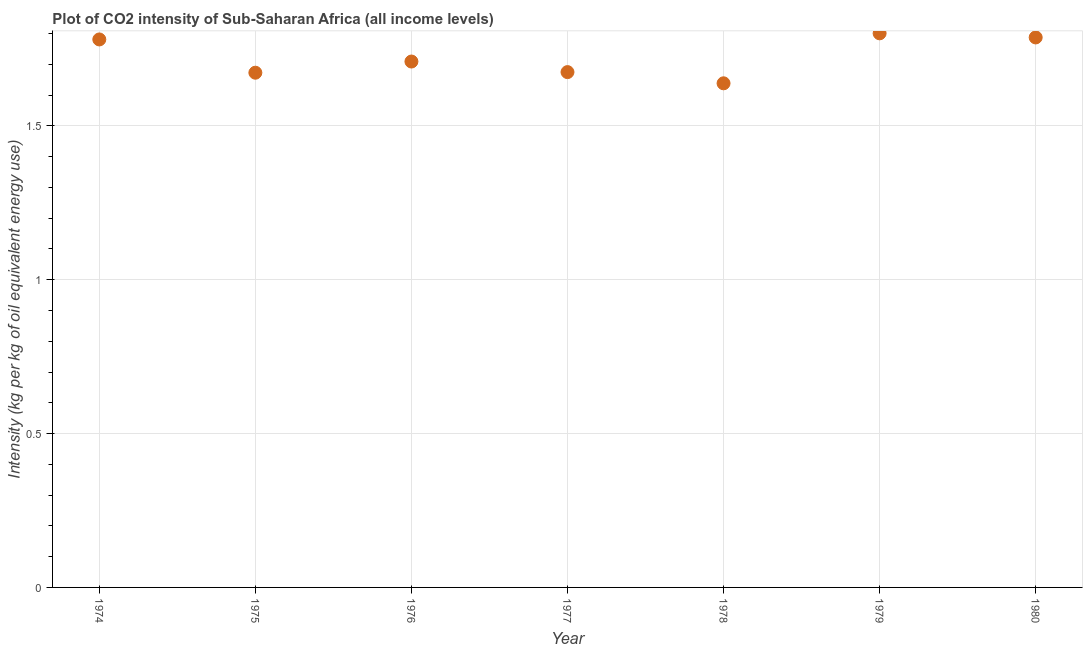What is the co2 intensity in 1980?
Your response must be concise. 1.79. Across all years, what is the maximum co2 intensity?
Your answer should be very brief. 1.8. Across all years, what is the minimum co2 intensity?
Keep it short and to the point. 1.64. In which year was the co2 intensity maximum?
Provide a short and direct response. 1979. In which year was the co2 intensity minimum?
Your answer should be very brief. 1978. What is the sum of the co2 intensity?
Make the answer very short. 12.06. What is the difference between the co2 intensity in 1974 and 1976?
Your answer should be compact. 0.07. What is the average co2 intensity per year?
Make the answer very short. 1.72. What is the median co2 intensity?
Your answer should be very brief. 1.71. In how many years, is the co2 intensity greater than 0.5 kg?
Provide a short and direct response. 7. What is the ratio of the co2 intensity in 1974 to that in 1978?
Your answer should be very brief. 1.09. Is the difference between the co2 intensity in 1974 and 1979 greater than the difference between any two years?
Your response must be concise. No. What is the difference between the highest and the second highest co2 intensity?
Offer a very short reply. 0.01. What is the difference between the highest and the lowest co2 intensity?
Give a very brief answer. 0.16. In how many years, is the co2 intensity greater than the average co2 intensity taken over all years?
Offer a very short reply. 3. How many years are there in the graph?
Provide a short and direct response. 7. Does the graph contain any zero values?
Your response must be concise. No. Does the graph contain grids?
Give a very brief answer. Yes. What is the title of the graph?
Give a very brief answer. Plot of CO2 intensity of Sub-Saharan Africa (all income levels). What is the label or title of the Y-axis?
Offer a terse response. Intensity (kg per kg of oil equivalent energy use). What is the Intensity (kg per kg of oil equivalent energy use) in 1974?
Offer a very short reply. 1.78. What is the Intensity (kg per kg of oil equivalent energy use) in 1975?
Your answer should be compact. 1.67. What is the Intensity (kg per kg of oil equivalent energy use) in 1976?
Give a very brief answer. 1.71. What is the Intensity (kg per kg of oil equivalent energy use) in 1977?
Offer a very short reply. 1.67. What is the Intensity (kg per kg of oil equivalent energy use) in 1978?
Offer a terse response. 1.64. What is the Intensity (kg per kg of oil equivalent energy use) in 1979?
Keep it short and to the point. 1.8. What is the Intensity (kg per kg of oil equivalent energy use) in 1980?
Offer a very short reply. 1.79. What is the difference between the Intensity (kg per kg of oil equivalent energy use) in 1974 and 1975?
Provide a succinct answer. 0.11. What is the difference between the Intensity (kg per kg of oil equivalent energy use) in 1974 and 1976?
Give a very brief answer. 0.07. What is the difference between the Intensity (kg per kg of oil equivalent energy use) in 1974 and 1977?
Make the answer very short. 0.11. What is the difference between the Intensity (kg per kg of oil equivalent energy use) in 1974 and 1978?
Your answer should be compact. 0.14. What is the difference between the Intensity (kg per kg of oil equivalent energy use) in 1974 and 1979?
Your answer should be very brief. -0.02. What is the difference between the Intensity (kg per kg of oil equivalent energy use) in 1974 and 1980?
Make the answer very short. -0.01. What is the difference between the Intensity (kg per kg of oil equivalent energy use) in 1975 and 1976?
Provide a short and direct response. -0.04. What is the difference between the Intensity (kg per kg of oil equivalent energy use) in 1975 and 1977?
Your answer should be very brief. -0. What is the difference between the Intensity (kg per kg of oil equivalent energy use) in 1975 and 1978?
Your answer should be very brief. 0.03. What is the difference between the Intensity (kg per kg of oil equivalent energy use) in 1975 and 1979?
Provide a succinct answer. -0.13. What is the difference between the Intensity (kg per kg of oil equivalent energy use) in 1975 and 1980?
Give a very brief answer. -0.11. What is the difference between the Intensity (kg per kg of oil equivalent energy use) in 1976 and 1977?
Provide a succinct answer. 0.03. What is the difference between the Intensity (kg per kg of oil equivalent energy use) in 1976 and 1978?
Provide a short and direct response. 0.07. What is the difference between the Intensity (kg per kg of oil equivalent energy use) in 1976 and 1979?
Keep it short and to the point. -0.09. What is the difference between the Intensity (kg per kg of oil equivalent energy use) in 1976 and 1980?
Offer a terse response. -0.08. What is the difference between the Intensity (kg per kg of oil equivalent energy use) in 1977 and 1978?
Your response must be concise. 0.04. What is the difference between the Intensity (kg per kg of oil equivalent energy use) in 1977 and 1979?
Provide a succinct answer. -0.13. What is the difference between the Intensity (kg per kg of oil equivalent energy use) in 1977 and 1980?
Ensure brevity in your answer.  -0.11. What is the difference between the Intensity (kg per kg of oil equivalent energy use) in 1978 and 1979?
Make the answer very short. -0.16. What is the difference between the Intensity (kg per kg of oil equivalent energy use) in 1978 and 1980?
Offer a very short reply. -0.15. What is the difference between the Intensity (kg per kg of oil equivalent energy use) in 1979 and 1980?
Your response must be concise. 0.01. What is the ratio of the Intensity (kg per kg of oil equivalent energy use) in 1974 to that in 1975?
Offer a very short reply. 1.06. What is the ratio of the Intensity (kg per kg of oil equivalent energy use) in 1974 to that in 1976?
Your response must be concise. 1.04. What is the ratio of the Intensity (kg per kg of oil equivalent energy use) in 1974 to that in 1977?
Give a very brief answer. 1.06. What is the ratio of the Intensity (kg per kg of oil equivalent energy use) in 1974 to that in 1978?
Provide a succinct answer. 1.09. What is the ratio of the Intensity (kg per kg of oil equivalent energy use) in 1974 to that in 1979?
Ensure brevity in your answer.  0.99. What is the ratio of the Intensity (kg per kg of oil equivalent energy use) in 1975 to that in 1978?
Ensure brevity in your answer.  1.02. What is the ratio of the Intensity (kg per kg of oil equivalent energy use) in 1975 to that in 1979?
Keep it short and to the point. 0.93. What is the ratio of the Intensity (kg per kg of oil equivalent energy use) in 1975 to that in 1980?
Keep it short and to the point. 0.94. What is the ratio of the Intensity (kg per kg of oil equivalent energy use) in 1976 to that in 1977?
Offer a terse response. 1.02. What is the ratio of the Intensity (kg per kg of oil equivalent energy use) in 1976 to that in 1978?
Keep it short and to the point. 1.04. What is the ratio of the Intensity (kg per kg of oil equivalent energy use) in 1976 to that in 1979?
Offer a very short reply. 0.95. What is the ratio of the Intensity (kg per kg of oil equivalent energy use) in 1976 to that in 1980?
Your answer should be very brief. 0.96. What is the ratio of the Intensity (kg per kg of oil equivalent energy use) in 1977 to that in 1979?
Provide a succinct answer. 0.93. What is the ratio of the Intensity (kg per kg of oil equivalent energy use) in 1977 to that in 1980?
Your answer should be compact. 0.94. What is the ratio of the Intensity (kg per kg of oil equivalent energy use) in 1978 to that in 1979?
Your response must be concise. 0.91. What is the ratio of the Intensity (kg per kg of oil equivalent energy use) in 1978 to that in 1980?
Your answer should be compact. 0.92. 